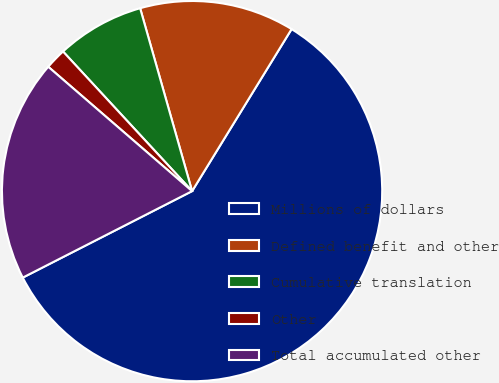<chart> <loc_0><loc_0><loc_500><loc_500><pie_chart><fcel>Millions of dollars<fcel>Defined benefit and other<fcel>Cumulative translation<fcel>Other<fcel>Total accumulated other<nl><fcel>58.72%<fcel>13.17%<fcel>7.47%<fcel>1.78%<fcel>18.86%<nl></chart> 